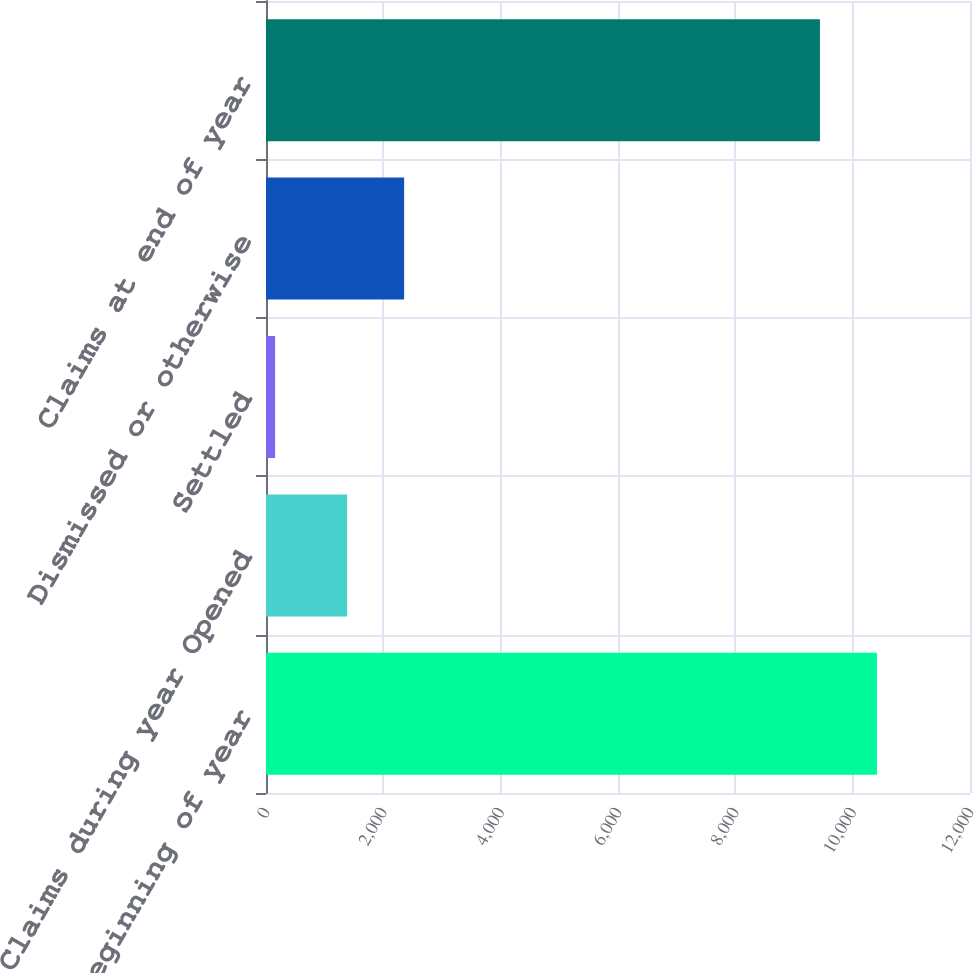Convert chart. <chart><loc_0><loc_0><loc_500><loc_500><bar_chart><fcel>Claims at beginning of year<fcel>Claims during year Opened<fcel>Settled<fcel>Dismissed or otherwise<fcel>Claims at end of year<nl><fcel>10413.8<fcel>1383<fcel>155<fcel>2354.8<fcel>9442<nl></chart> 